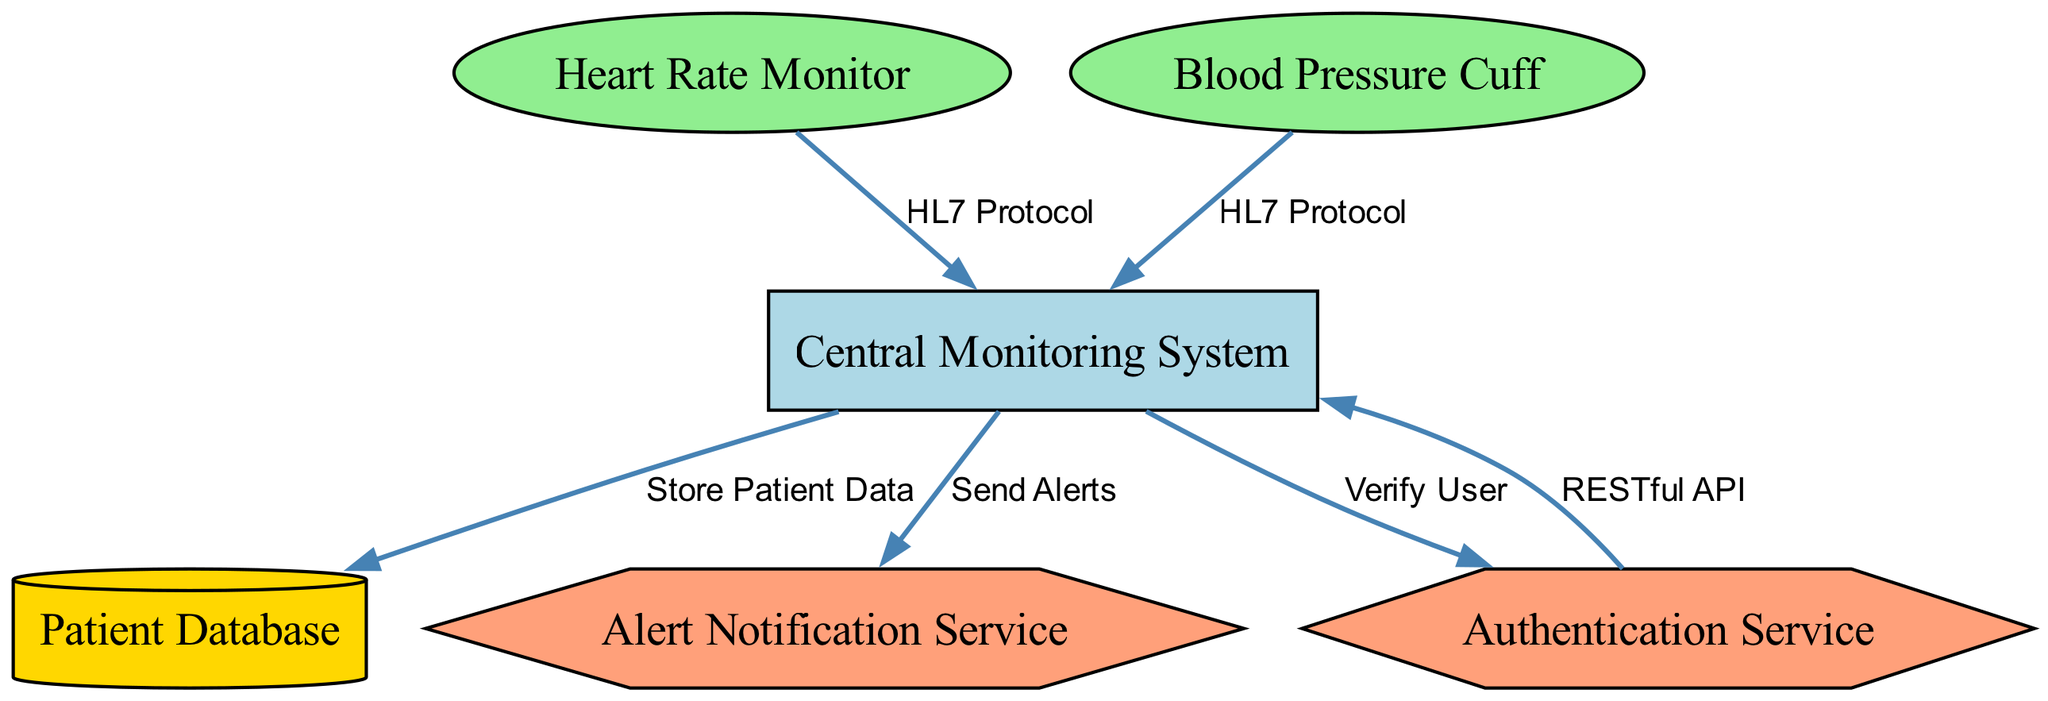What is the central node in the diagram? The central node is identified as "Central Monitoring System," which is the main hub connecting various devices and services in the overall architecture.
Answer: Central Monitoring System How many medical devices are shown in the diagram? The diagram includes two medical devices, specifically "Heart Rate Monitor" and "Blood Pressure Cuff," that are represented as nodes in the architecture.
Answer: 2 What protocol connects the heart rate monitor to the central monitoring system? The connection between the "Heart Rate Monitor" and the "Central Monitoring System" is made using the "HL7 Protocol," which is indicated on the edge between these two nodes.
Answer: HL7 Protocol Which service verifies the user in this architecture? The "Authentication Service" is responsible for verifying the user, as shown by the edge from "Central Monitoring System" to "Authentication Service" labeled with "Verify User."
Answer: Authentication Service What type of database is included in the diagram? The database included in the diagram is labeled as "Patient Database," which is depicted as a cylinder, indicating its role in storing patient information.
Answer: Patient Database Which service sends alerts to the central monitoring system? The "Alert Notification Service" is designated to send alerts to the "Central Monitoring System," as illustrated by the directed edge labeled "Send Alerts."
Answer: Alert Notification Service How many edges are present in the diagram? The diagram has a total of five edges, representing the connections between devices, services, and databases outlined in the structure.
Answer: 5 What is the relationship between the authentication service and the central monitoring system? The relationship is established through a connection labeled "RESTful API" which indicates that the "Authentication Service" communicates with the "Central Monitoring System" using this type of API.
Answer: RESTful API What do the heart rate monitor and blood pressure cuff share in their connection to the central monitoring system? Both medical devices share the same connection method to the "Central Monitoring System", utilizing the "HL7 Protocol" for their data transfer.
Answer: HL7 Protocol 